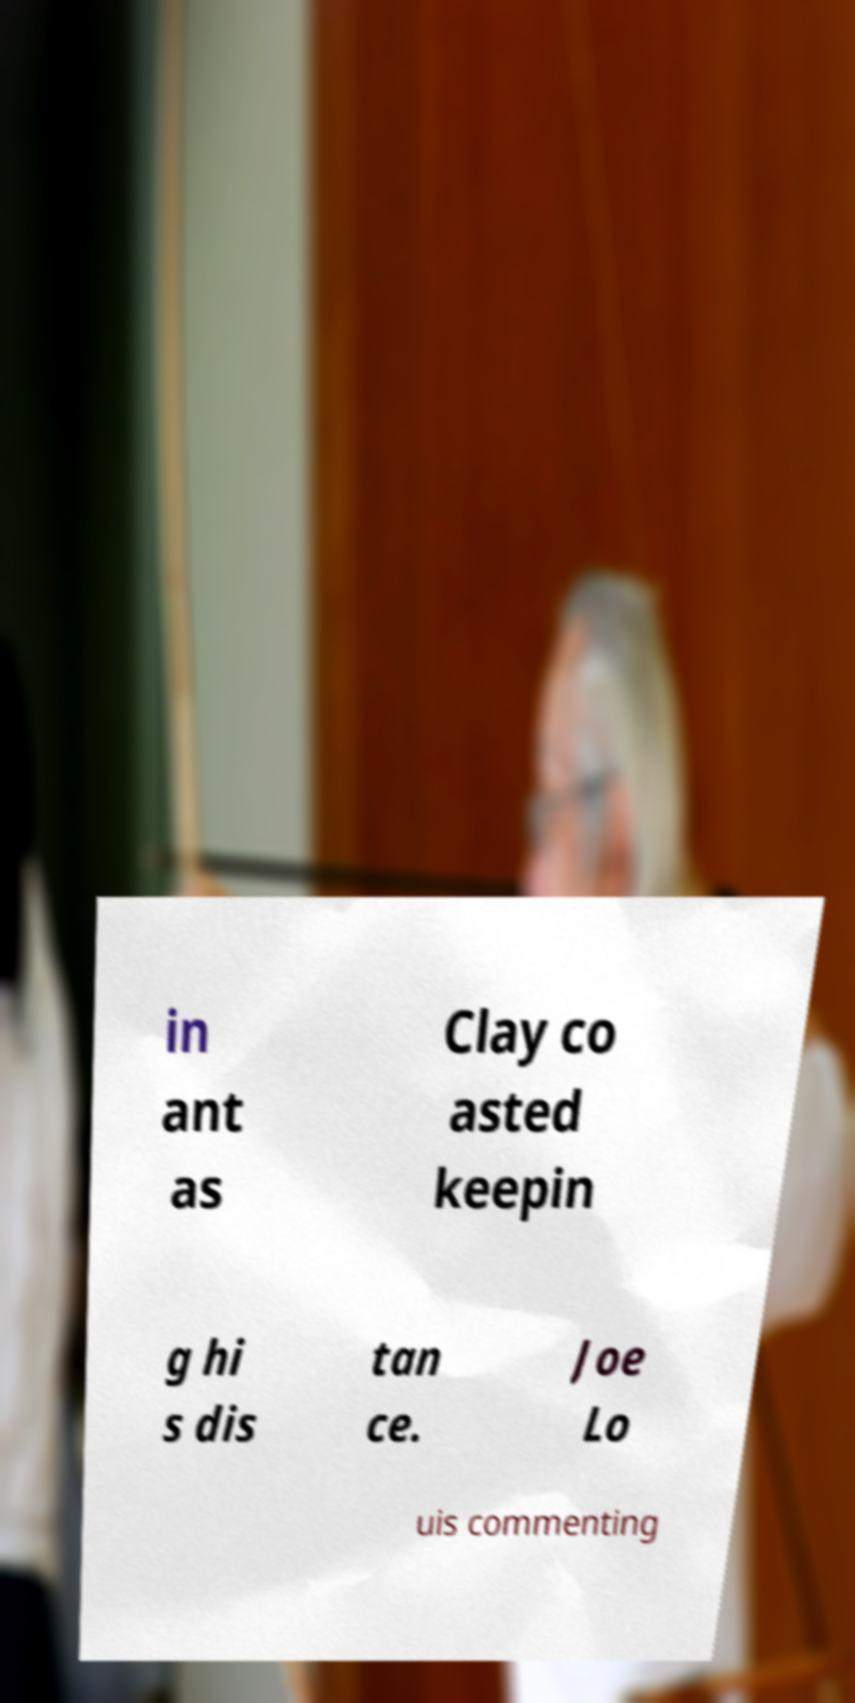For documentation purposes, I need the text within this image transcribed. Could you provide that? in ant as Clay co asted keepin g hi s dis tan ce. Joe Lo uis commenting 